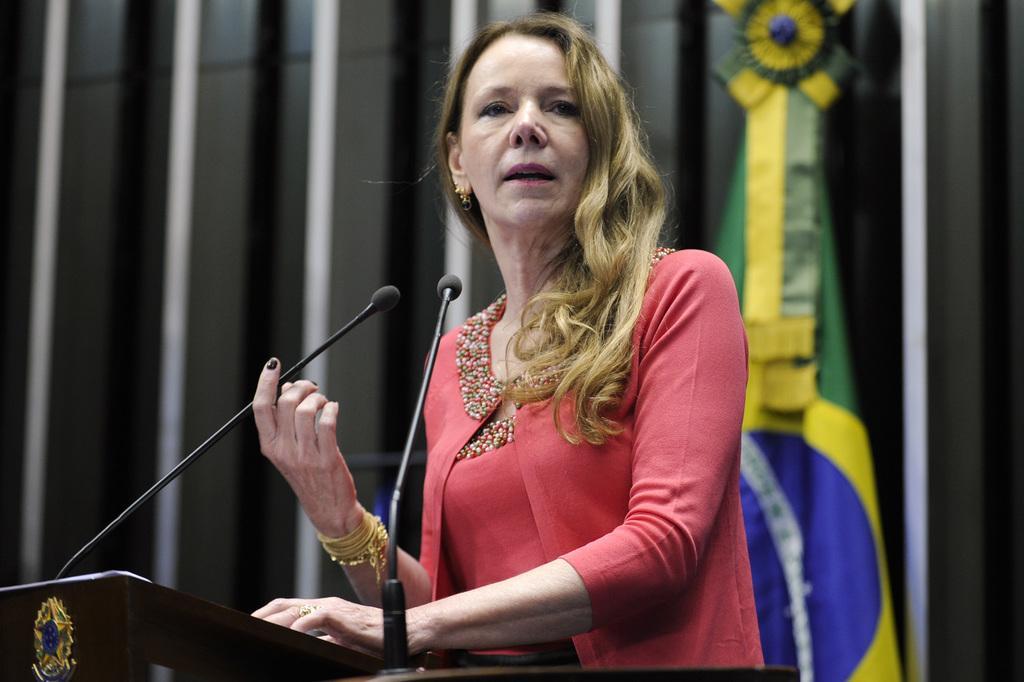Can you describe this image briefly? Woman standing,there is microphone and in the back there is flag. 